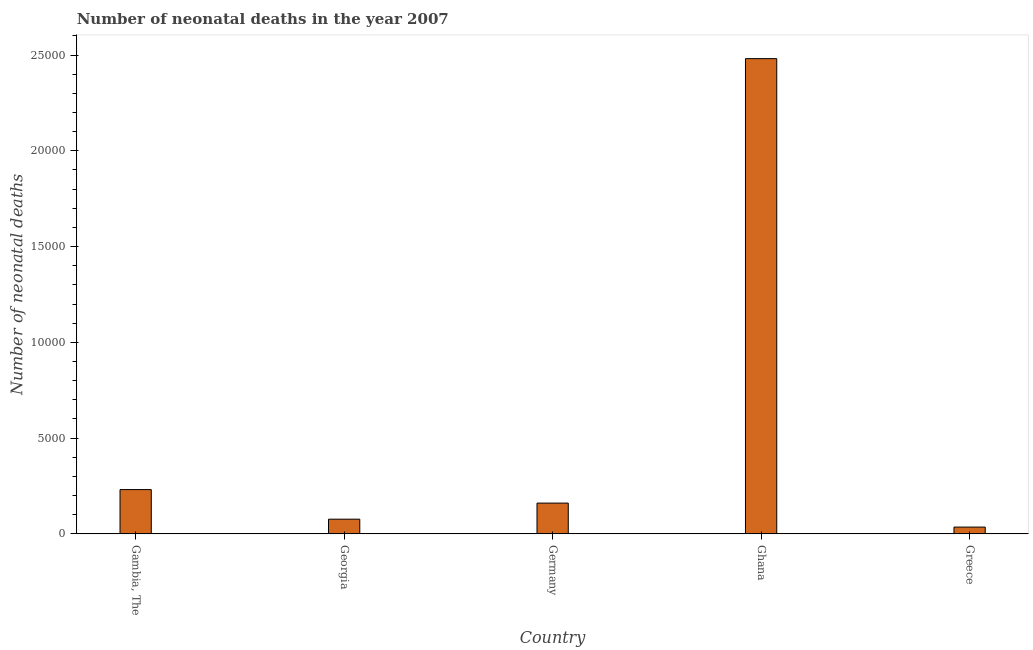Does the graph contain grids?
Offer a terse response. No. What is the title of the graph?
Offer a terse response. Number of neonatal deaths in the year 2007. What is the label or title of the X-axis?
Give a very brief answer. Country. What is the label or title of the Y-axis?
Your answer should be compact. Number of neonatal deaths. What is the number of neonatal deaths in Greece?
Make the answer very short. 354. Across all countries, what is the maximum number of neonatal deaths?
Provide a succinct answer. 2.48e+04. Across all countries, what is the minimum number of neonatal deaths?
Provide a succinct answer. 354. In which country was the number of neonatal deaths maximum?
Provide a short and direct response. Ghana. What is the sum of the number of neonatal deaths?
Your answer should be compact. 2.99e+04. What is the difference between the number of neonatal deaths in Georgia and Ghana?
Ensure brevity in your answer.  -2.40e+04. What is the average number of neonatal deaths per country?
Ensure brevity in your answer.  5970. What is the median number of neonatal deaths?
Your response must be concise. 1606. In how many countries, is the number of neonatal deaths greater than 4000 ?
Give a very brief answer. 1. What is the ratio of the number of neonatal deaths in Gambia, The to that in Germany?
Keep it short and to the point. 1.44. Is the difference between the number of neonatal deaths in Germany and Greece greater than the difference between any two countries?
Keep it short and to the point. No. What is the difference between the highest and the second highest number of neonatal deaths?
Provide a short and direct response. 2.25e+04. What is the difference between the highest and the lowest number of neonatal deaths?
Give a very brief answer. 2.45e+04. In how many countries, is the number of neonatal deaths greater than the average number of neonatal deaths taken over all countries?
Your response must be concise. 1. How many bars are there?
Make the answer very short. 5. Are all the bars in the graph horizontal?
Offer a very short reply. No. What is the difference between two consecutive major ticks on the Y-axis?
Ensure brevity in your answer.  5000. Are the values on the major ticks of Y-axis written in scientific E-notation?
Ensure brevity in your answer.  No. What is the Number of neonatal deaths in Gambia, The?
Make the answer very short. 2312. What is the Number of neonatal deaths in Georgia?
Your response must be concise. 767. What is the Number of neonatal deaths of Germany?
Your answer should be very brief. 1606. What is the Number of neonatal deaths of Ghana?
Offer a terse response. 2.48e+04. What is the Number of neonatal deaths in Greece?
Offer a very short reply. 354. What is the difference between the Number of neonatal deaths in Gambia, The and Georgia?
Make the answer very short. 1545. What is the difference between the Number of neonatal deaths in Gambia, The and Germany?
Offer a very short reply. 706. What is the difference between the Number of neonatal deaths in Gambia, The and Ghana?
Your response must be concise. -2.25e+04. What is the difference between the Number of neonatal deaths in Gambia, The and Greece?
Your response must be concise. 1958. What is the difference between the Number of neonatal deaths in Georgia and Germany?
Your answer should be compact. -839. What is the difference between the Number of neonatal deaths in Georgia and Ghana?
Offer a very short reply. -2.40e+04. What is the difference between the Number of neonatal deaths in Georgia and Greece?
Your answer should be compact. 413. What is the difference between the Number of neonatal deaths in Germany and Ghana?
Your answer should be compact. -2.32e+04. What is the difference between the Number of neonatal deaths in Germany and Greece?
Your answer should be compact. 1252. What is the difference between the Number of neonatal deaths in Ghana and Greece?
Offer a terse response. 2.45e+04. What is the ratio of the Number of neonatal deaths in Gambia, The to that in Georgia?
Offer a terse response. 3.01. What is the ratio of the Number of neonatal deaths in Gambia, The to that in Germany?
Give a very brief answer. 1.44. What is the ratio of the Number of neonatal deaths in Gambia, The to that in Ghana?
Offer a very short reply. 0.09. What is the ratio of the Number of neonatal deaths in Gambia, The to that in Greece?
Provide a succinct answer. 6.53. What is the ratio of the Number of neonatal deaths in Georgia to that in Germany?
Provide a short and direct response. 0.48. What is the ratio of the Number of neonatal deaths in Georgia to that in Ghana?
Keep it short and to the point. 0.03. What is the ratio of the Number of neonatal deaths in Georgia to that in Greece?
Offer a very short reply. 2.17. What is the ratio of the Number of neonatal deaths in Germany to that in Ghana?
Your answer should be compact. 0.07. What is the ratio of the Number of neonatal deaths in Germany to that in Greece?
Make the answer very short. 4.54. What is the ratio of the Number of neonatal deaths in Ghana to that in Greece?
Your answer should be very brief. 70.1. 